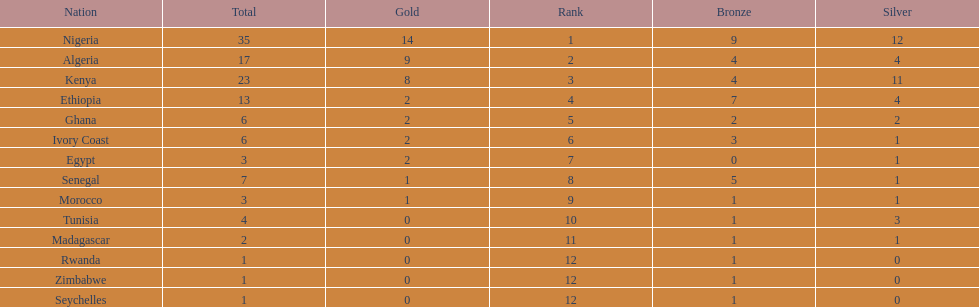The country that won the most medals was? Nigeria. 